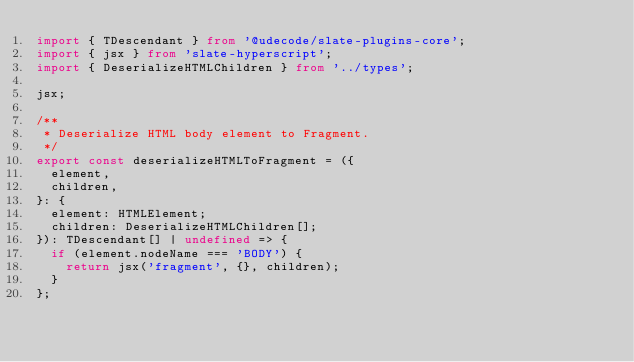<code> <loc_0><loc_0><loc_500><loc_500><_TypeScript_>import { TDescendant } from '@udecode/slate-plugins-core';
import { jsx } from 'slate-hyperscript';
import { DeserializeHTMLChildren } from '../types';

jsx;

/**
 * Deserialize HTML body element to Fragment.
 */
export const deserializeHTMLToFragment = ({
  element,
  children,
}: {
  element: HTMLElement;
  children: DeserializeHTMLChildren[];
}): TDescendant[] | undefined => {
  if (element.nodeName === 'BODY') {
    return jsx('fragment', {}, children);
  }
};
</code> 